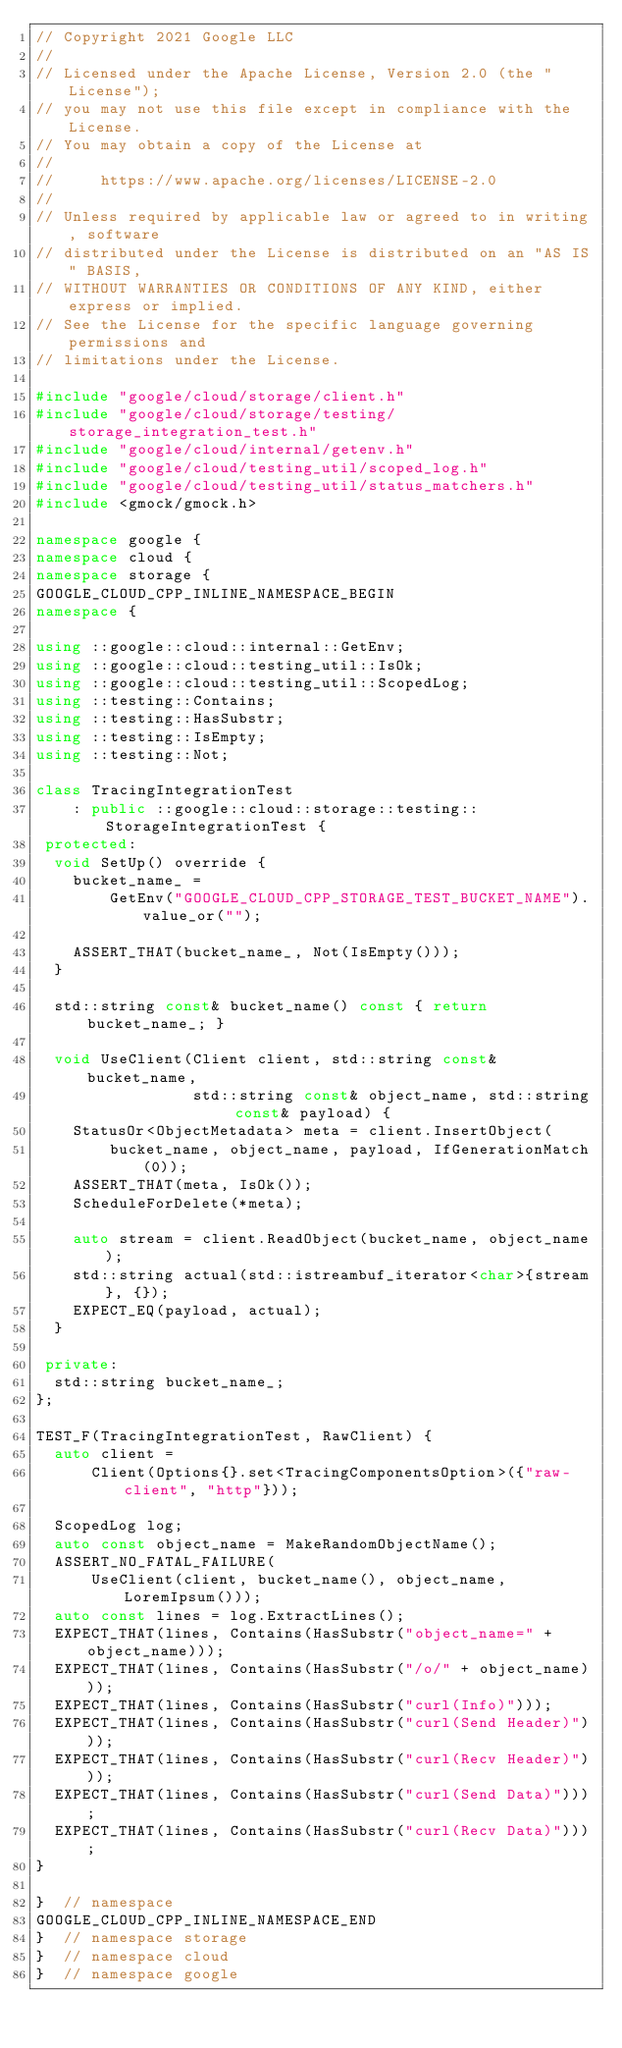<code> <loc_0><loc_0><loc_500><loc_500><_C++_>// Copyright 2021 Google LLC
//
// Licensed under the Apache License, Version 2.0 (the "License");
// you may not use this file except in compliance with the License.
// You may obtain a copy of the License at
//
//     https://www.apache.org/licenses/LICENSE-2.0
//
// Unless required by applicable law or agreed to in writing, software
// distributed under the License is distributed on an "AS IS" BASIS,
// WITHOUT WARRANTIES OR CONDITIONS OF ANY KIND, either express or implied.
// See the License for the specific language governing permissions and
// limitations under the License.

#include "google/cloud/storage/client.h"
#include "google/cloud/storage/testing/storage_integration_test.h"
#include "google/cloud/internal/getenv.h"
#include "google/cloud/testing_util/scoped_log.h"
#include "google/cloud/testing_util/status_matchers.h"
#include <gmock/gmock.h>

namespace google {
namespace cloud {
namespace storage {
GOOGLE_CLOUD_CPP_INLINE_NAMESPACE_BEGIN
namespace {

using ::google::cloud::internal::GetEnv;
using ::google::cloud::testing_util::IsOk;
using ::google::cloud::testing_util::ScopedLog;
using ::testing::Contains;
using ::testing::HasSubstr;
using ::testing::IsEmpty;
using ::testing::Not;

class TracingIntegrationTest
    : public ::google::cloud::storage::testing::StorageIntegrationTest {
 protected:
  void SetUp() override {
    bucket_name_ =
        GetEnv("GOOGLE_CLOUD_CPP_STORAGE_TEST_BUCKET_NAME").value_or("");

    ASSERT_THAT(bucket_name_, Not(IsEmpty()));
  }

  std::string const& bucket_name() const { return bucket_name_; }

  void UseClient(Client client, std::string const& bucket_name,
                 std::string const& object_name, std::string const& payload) {
    StatusOr<ObjectMetadata> meta = client.InsertObject(
        bucket_name, object_name, payload, IfGenerationMatch(0));
    ASSERT_THAT(meta, IsOk());
    ScheduleForDelete(*meta);

    auto stream = client.ReadObject(bucket_name, object_name);
    std::string actual(std::istreambuf_iterator<char>{stream}, {});
    EXPECT_EQ(payload, actual);
  }

 private:
  std::string bucket_name_;
};

TEST_F(TracingIntegrationTest, RawClient) {
  auto client =
      Client(Options{}.set<TracingComponentsOption>({"raw-client", "http"}));

  ScopedLog log;
  auto const object_name = MakeRandomObjectName();
  ASSERT_NO_FATAL_FAILURE(
      UseClient(client, bucket_name(), object_name, LoremIpsum()));
  auto const lines = log.ExtractLines();
  EXPECT_THAT(lines, Contains(HasSubstr("object_name=" + object_name)));
  EXPECT_THAT(lines, Contains(HasSubstr("/o/" + object_name)));
  EXPECT_THAT(lines, Contains(HasSubstr("curl(Info)")));
  EXPECT_THAT(lines, Contains(HasSubstr("curl(Send Header)")));
  EXPECT_THAT(lines, Contains(HasSubstr("curl(Recv Header)")));
  EXPECT_THAT(lines, Contains(HasSubstr("curl(Send Data)")));
  EXPECT_THAT(lines, Contains(HasSubstr("curl(Recv Data)")));
}

}  // namespace
GOOGLE_CLOUD_CPP_INLINE_NAMESPACE_END
}  // namespace storage
}  // namespace cloud
}  // namespace google
</code> 